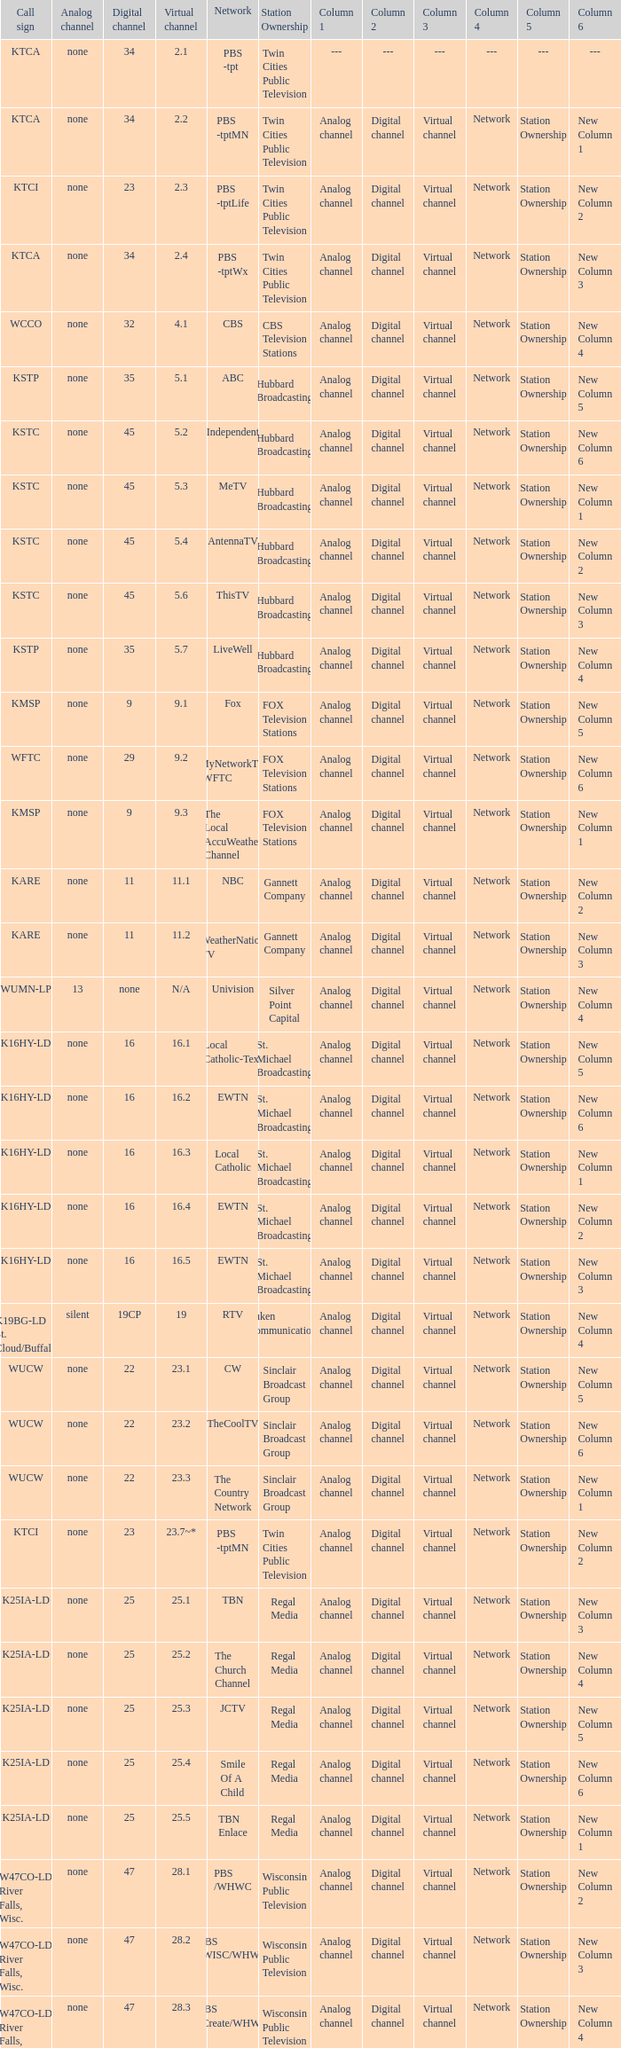Call sign of k43hb-ld is what virtual channel? 43.1. 